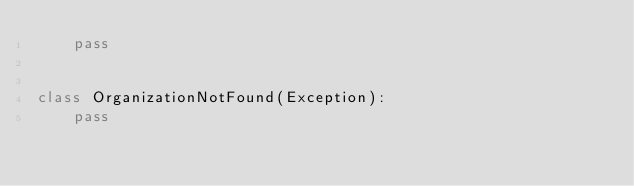Convert code to text. <code><loc_0><loc_0><loc_500><loc_500><_Python_>    pass


class OrganizationNotFound(Exception):
    pass
</code> 